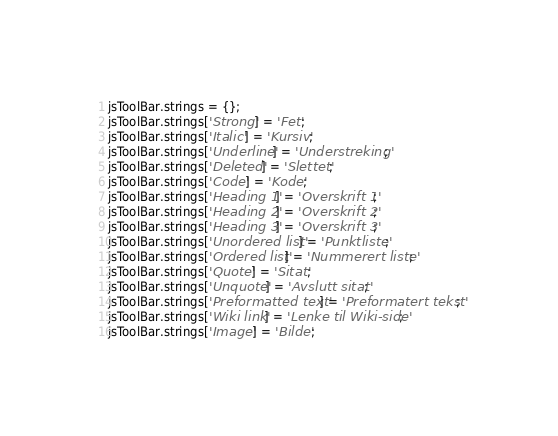<code> <loc_0><loc_0><loc_500><loc_500><_JavaScript_>jsToolBar.strings = {};
jsToolBar.strings['Strong'] = 'Fet';
jsToolBar.strings['Italic'] = 'Kursiv';
jsToolBar.strings['Underline'] = 'Understreking';
jsToolBar.strings['Deleted'] = 'Slettet';
jsToolBar.strings['Code'] = 'Kode';
jsToolBar.strings['Heading 1'] = 'Overskrift 1';
jsToolBar.strings['Heading 2'] = 'Overskrift 2';
jsToolBar.strings['Heading 3'] = 'Overskrift 3';
jsToolBar.strings['Unordered list'] = 'Punktliste';
jsToolBar.strings['Ordered list'] = 'Nummerert liste';
jsToolBar.strings['Quote'] = 'Sitat';
jsToolBar.strings['Unquote'] = 'Avslutt sitat';
jsToolBar.strings['Preformatted text'] = 'Preformatert tekst';
jsToolBar.strings['Wiki link'] = 'Lenke til Wiki-side';
jsToolBar.strings['Image'] = 'Bilde';
</code> 